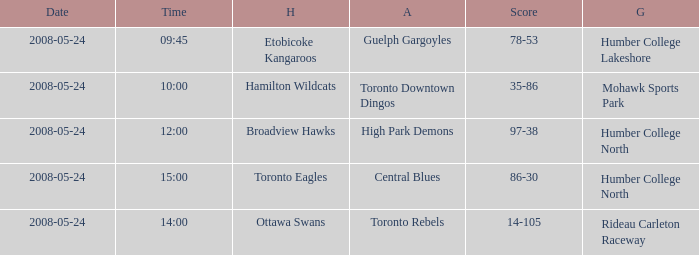Who was the home team of the game at the time of 15:00? Toronto Eagles. 